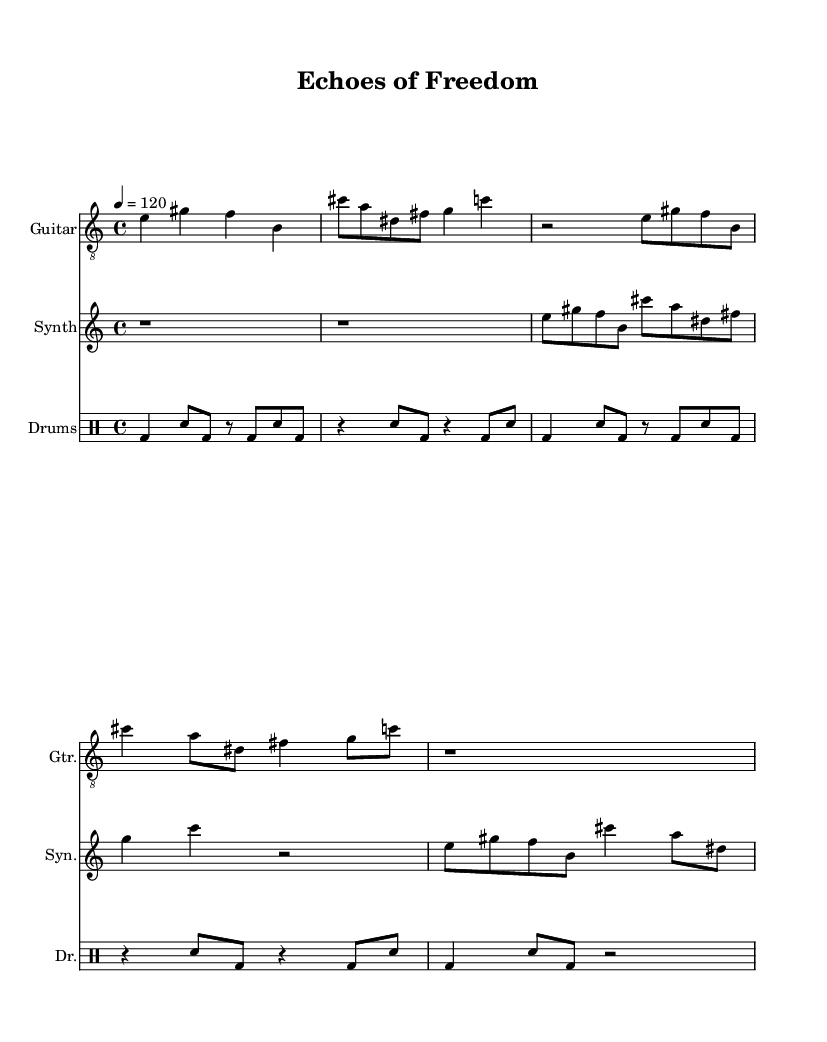What is the time signature of this music? The time signature is indicated at the beginning of the score, shown as "4/4." This means that there are four beats in each measure, and a quarter note receives one beat.
Answer: 4/4 What is the tempo marking in this score? The tempo marking is shown as "4 = 120" at the beginning, indicating that the quarter note should be played at 120 beats per minute.
Answer: 120 How many measures are in the guitar part? By analyzing the guitar part, we can count the number of measures based on the placement of the bar lines; there are eight measures present in the guitar staff.
Answer: 8 What type of musical form is predominantly used in this composition? Given that there are repetitive sections and contrasting textures in the guitar and synth parts with a consistent rhythmic pattern in the drum part, it suggests an experimental form, focusing more on sound texture and atmosphere.
Answer: Experimental Which instruments are featured in this score? The instruments are listed in the score header and can be seen in the separate staves: Guitar, Synth, and Drums, signifying a combination of melodic and rhythmic elements.
Answer: Guitar, Synth, Drums What is the rhythmic pattern of the bass drum? The rhythm is noted in the drum staff and follows a pattern of quarter and eighth notes which can be counted as "1 and 2 and 3 and 4," showcasing a driving beat typical for industrial noise music.
Answer: Varies What do the dynamics imply about the performative intention in this work? While specific dynamics aren't listed, the repetitive and intense nature of industrial noise music, along with the structure and elements presented, suggest an intention to create a sense of tension and release through volume and texture, leading to an experience of control and liberation.
Answer: Tension and release 